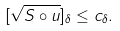Convert formula to latex. <formula><loc_0><loc_0><loc_500><loc_500>[ \sqrt { S \circ u } ] _ { \delta } \leq c _ { \delta } .</formula> 